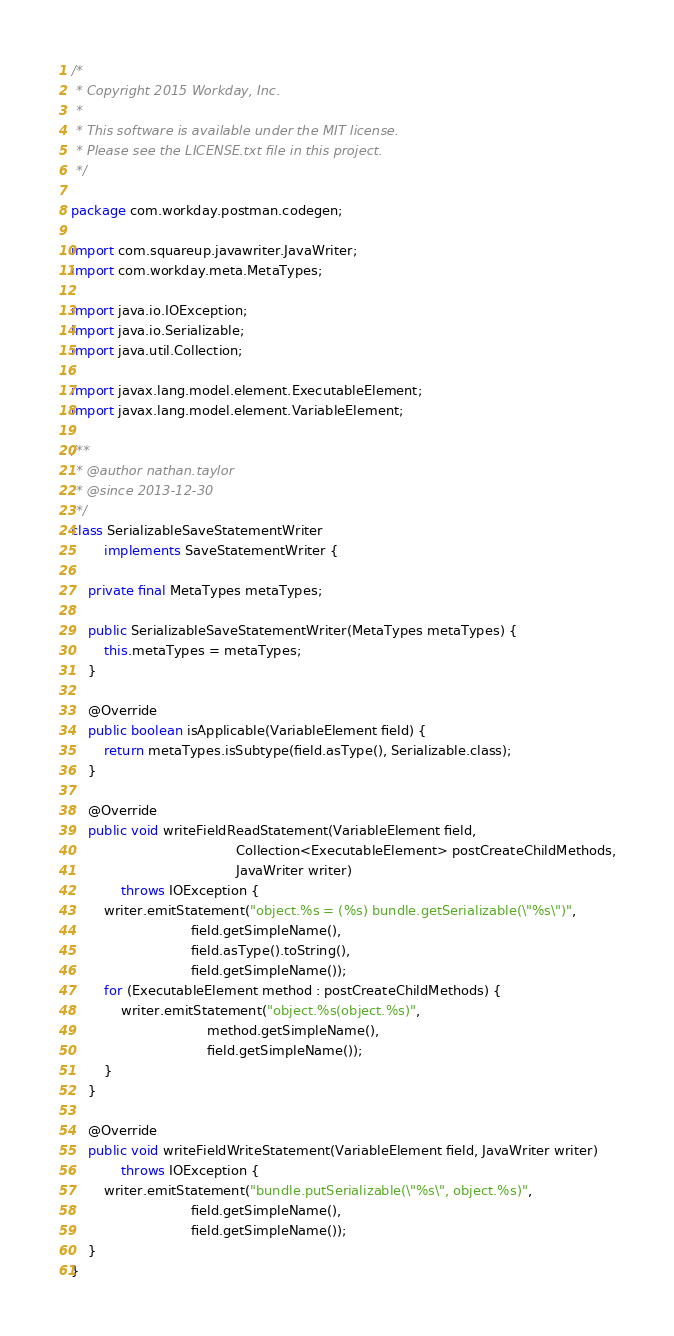<code> <loc_0><loc_0><loc_500><loc_500><_Java_>/*
 * Copyright 2015 Workday, Inc.
 *
 * This software is available under the MIT license.
 * Please see the LICENSE.txt file in this project.
 */

package com.workday.postman.codegen;

import com.squareup.javawriter.JavaWriter;
import com.workday.meta.MetaTypes;

import java.io.IOException;
import java.io.Serializable;
import java.util.Collection;

import javax.lang.model.element.ExecutableElement;
import javax.lang.model.element.VariableElement;

/**
 * @author nathan.taylor
 * @since 2013-12-30
 */
class SerializableSaveStatementWriter
        implements SaveStatementWriter {

    private final MetaTypes metaTypes;

    public SerializableSaveStatementWriter(MetaTypes metaTypes) {
        this.metaTypes = metaTypes;
    }

    @Override
    public boolean isApplicable(VariableElement field) {
        return metaTypes.isSubtype(field.asType(), Serializable.class);
    }

    @Override
    public void writeFieldReadStatement(VariableElement field,
                                        Collection<ExecutableElement> postCreateChildMethods,
                                        JavaWriter writer)
            throws IOException {
        writer.emitStatement("object.%s = (%s) bundle.getSerializable(\"%s\")",
                             field.getSimpleName(),
                             field.asType().toString(),
                             field.getSimpleName());
        for (ExecutableElement method : postCreateChildMethods) {
            writer.emitStatement("object.%s(object.%s)",
                                 method.getSimpleName(),
                                 field.getSimpleName());
        }
    }

    @Override
    public void writeFieldWriteStatement(VariableElement field, JavaWriter writer)
            throws IOException {
        writer.emitStatement("bundle.putSerializable(\"%s\", object.%s)",
                             field.getSimpleName(),
                             field.getSimpleName());
    }
}
</code> 